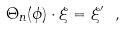Convert formula to latex. <formula><loc_0><loc_0><loc_500><loc_500>\Theta _ { n } ( \phi ) \cdot \xi = \xi ^ { \prime } \ ,</formula> 